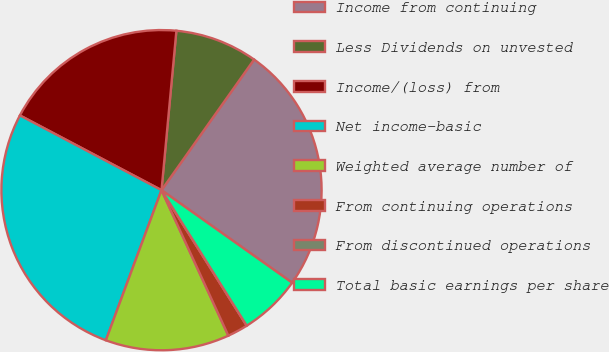Convert chart. <chart><loc_0><loc_0><loc_500><loc_500><pie_chart><fcel>Income from continuing<fcel>Less Dividends on unvested<fcel>Income/(loss) from<fcel>Net income-basic<fcel>Weighted average number of<fcel>From continuing operations<fcel>From discontinued operations<fcel>Total basic earnings per share<nl><fcel>25.0%<fcel>8.33%<fcel>18.75%<fcel>27.08%<fcel>12.5%<fcel>2.08%<fcel>0.0%<fcel>6.25%<nl></chart> 